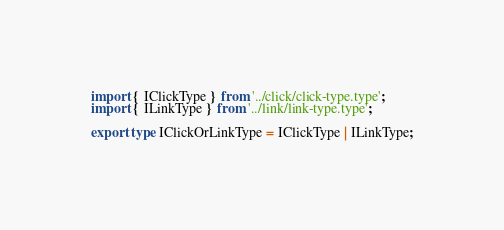Convert code to text. <code><loc_0><loc_0><loc_500><loc_500><_TypeScript_>import { IClickType } from '../click/click-type.type';
import { ILinkType } from '../link/link-type.type';

export type IClickOrLinkType = IClickType | ILinkType;

</code> 